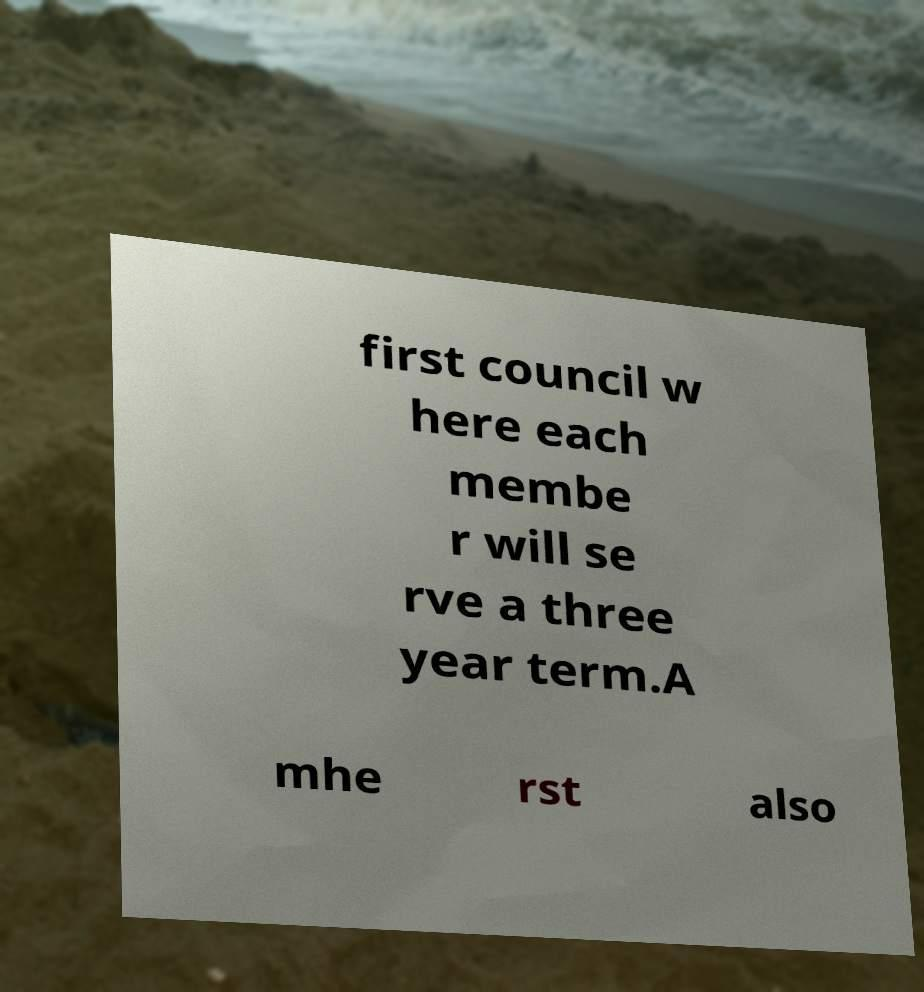There's text embedded in this image that I need extracted. Can you transcribe it verbatim? first council w here each membe r will se rve a three year term.A mhe rst also 